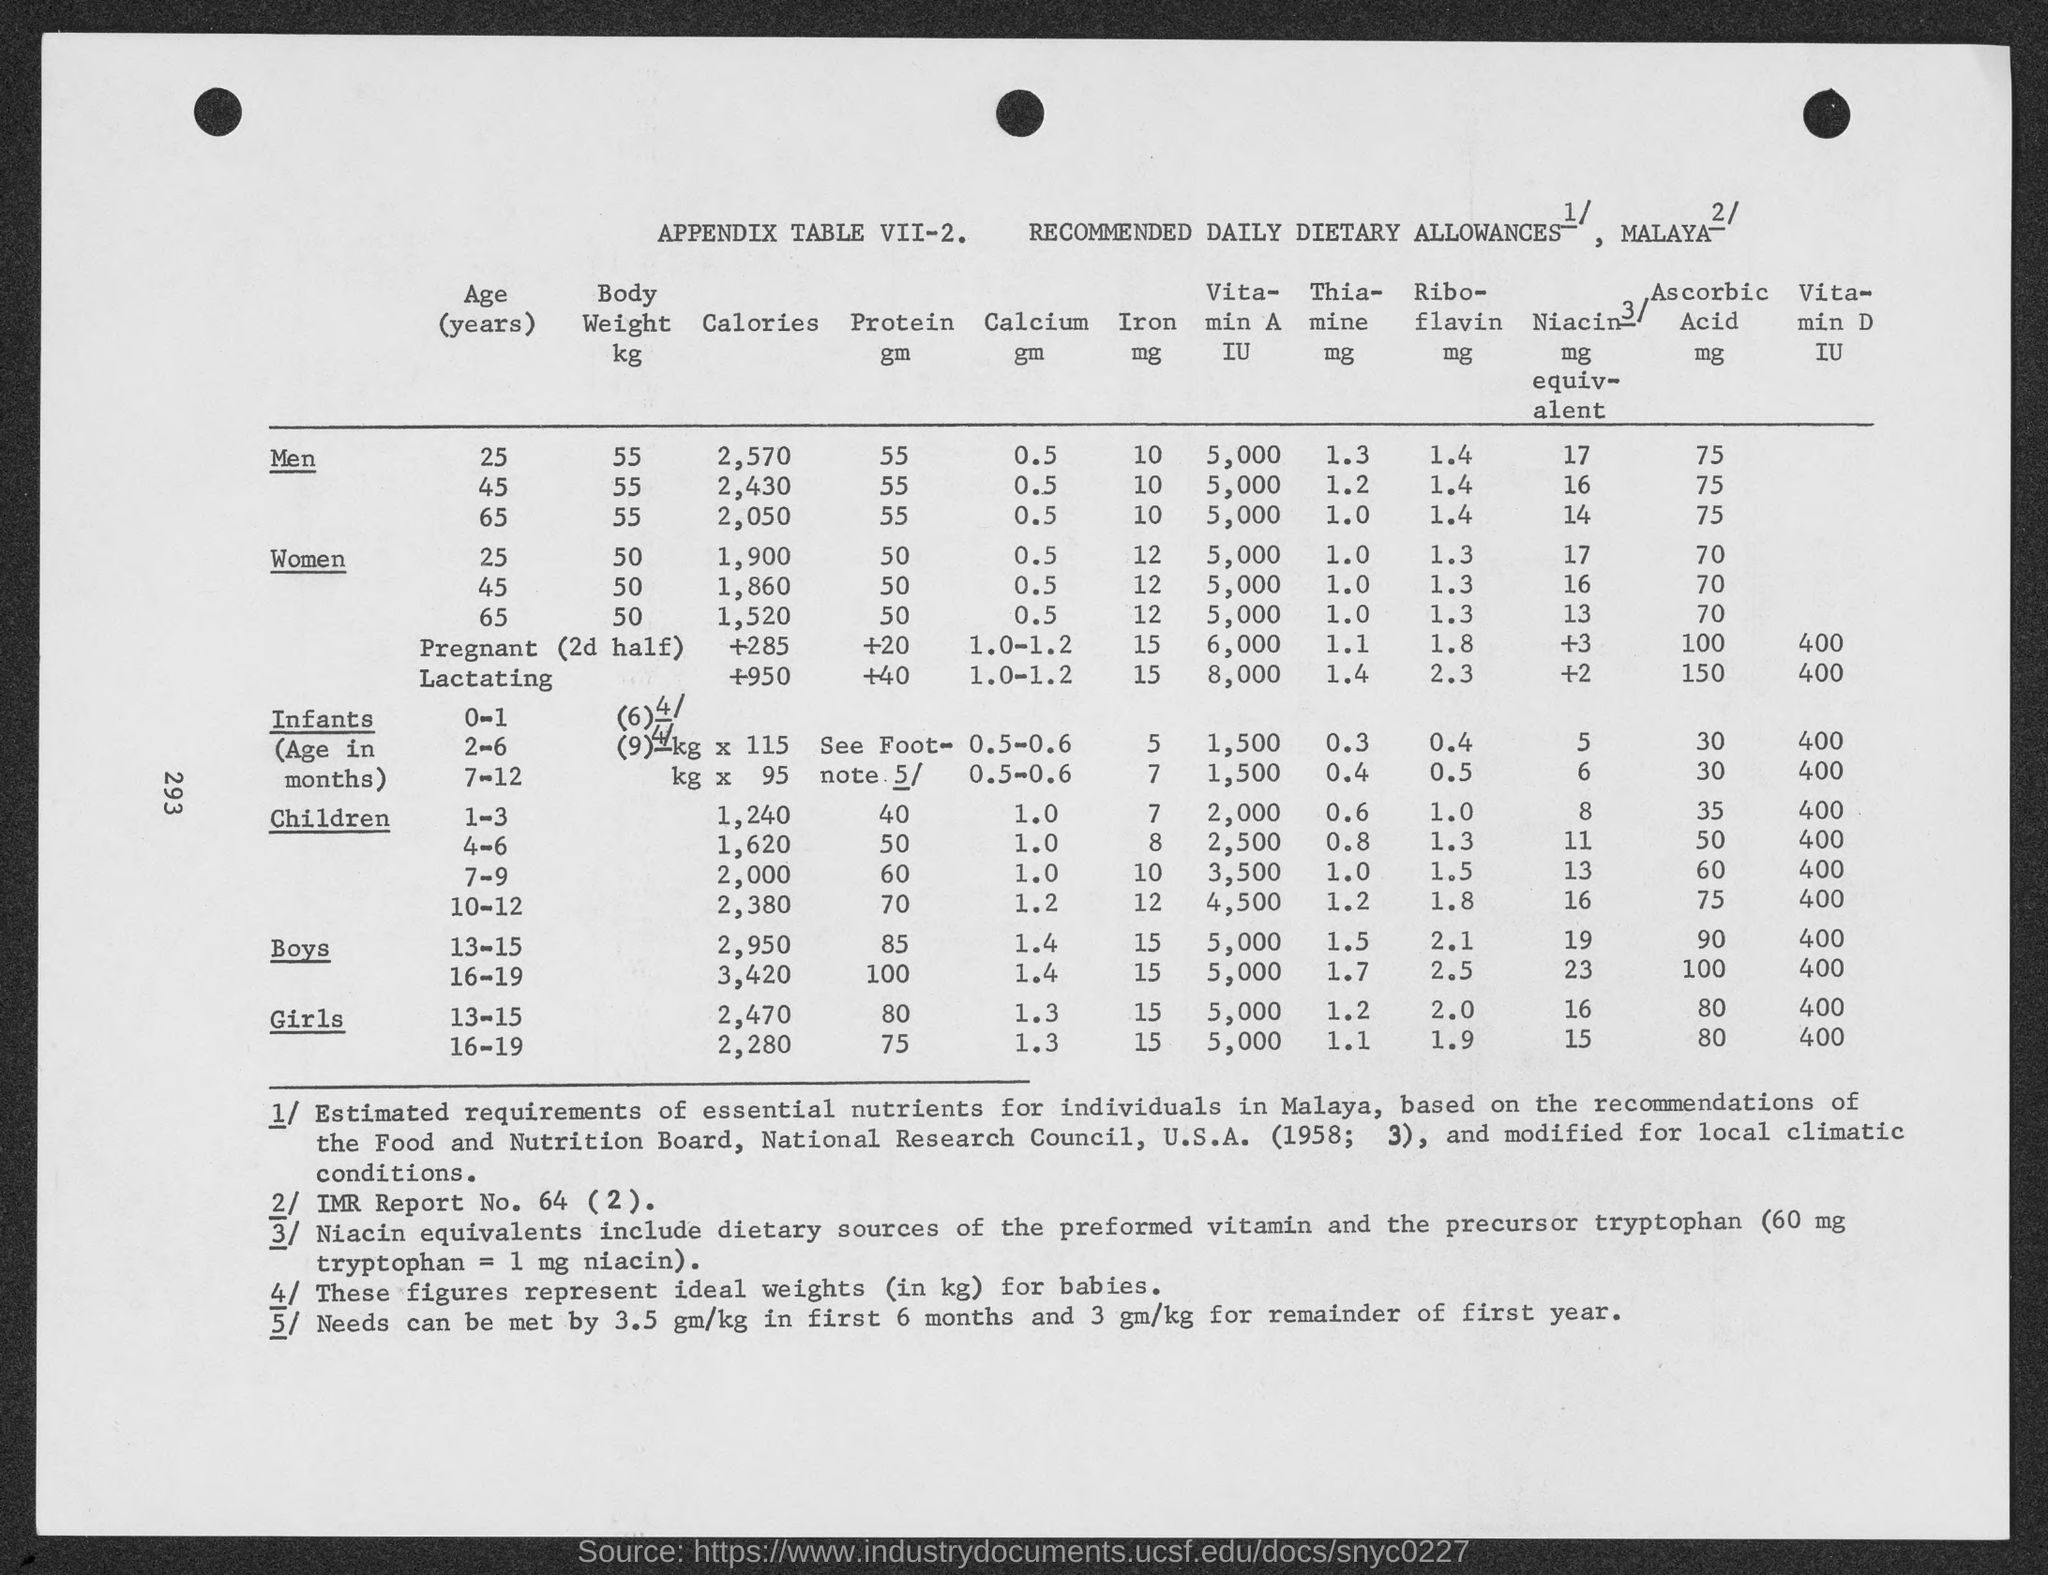Outline some significant characteristics in this image. There are approximately 2,570 calories in a 25-year-old man. The body weight of a 25-year-old man is represented in the table, and the information is converted to kilograms. 